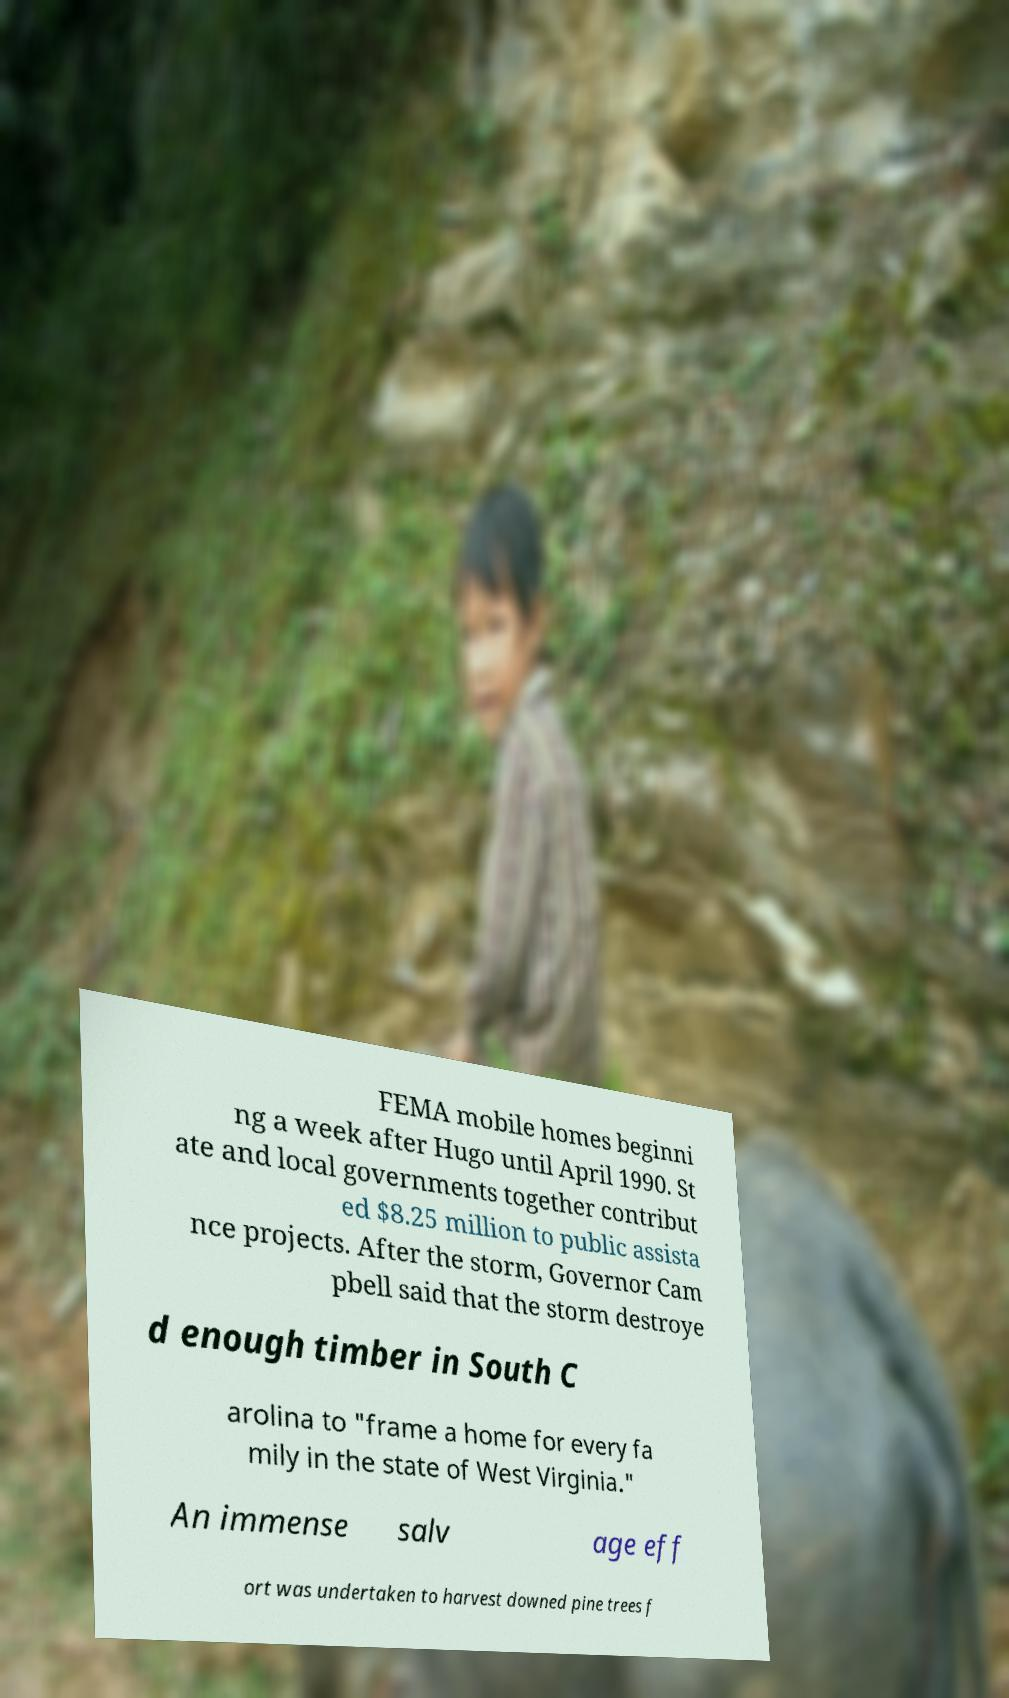Could you extract and type out the text from this image? FEMA mobile homes beginni ng a week after Hugo until April 1990. St ate and local governments together contribut ed $8.25 million to public assista nce projects. After the storm, Governor Cam pbell said that the storm destroye d enough timber in South C arolina to "frame a home for every fa mily in the state of West Virginia." An immense salv age eff ort was undertaken to harvest downed pine trees f 